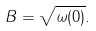<formula> <loc_0><loc_0><loc_500><loc_500>B = \sqrt { \omega ( 0 ) } .</formula> 